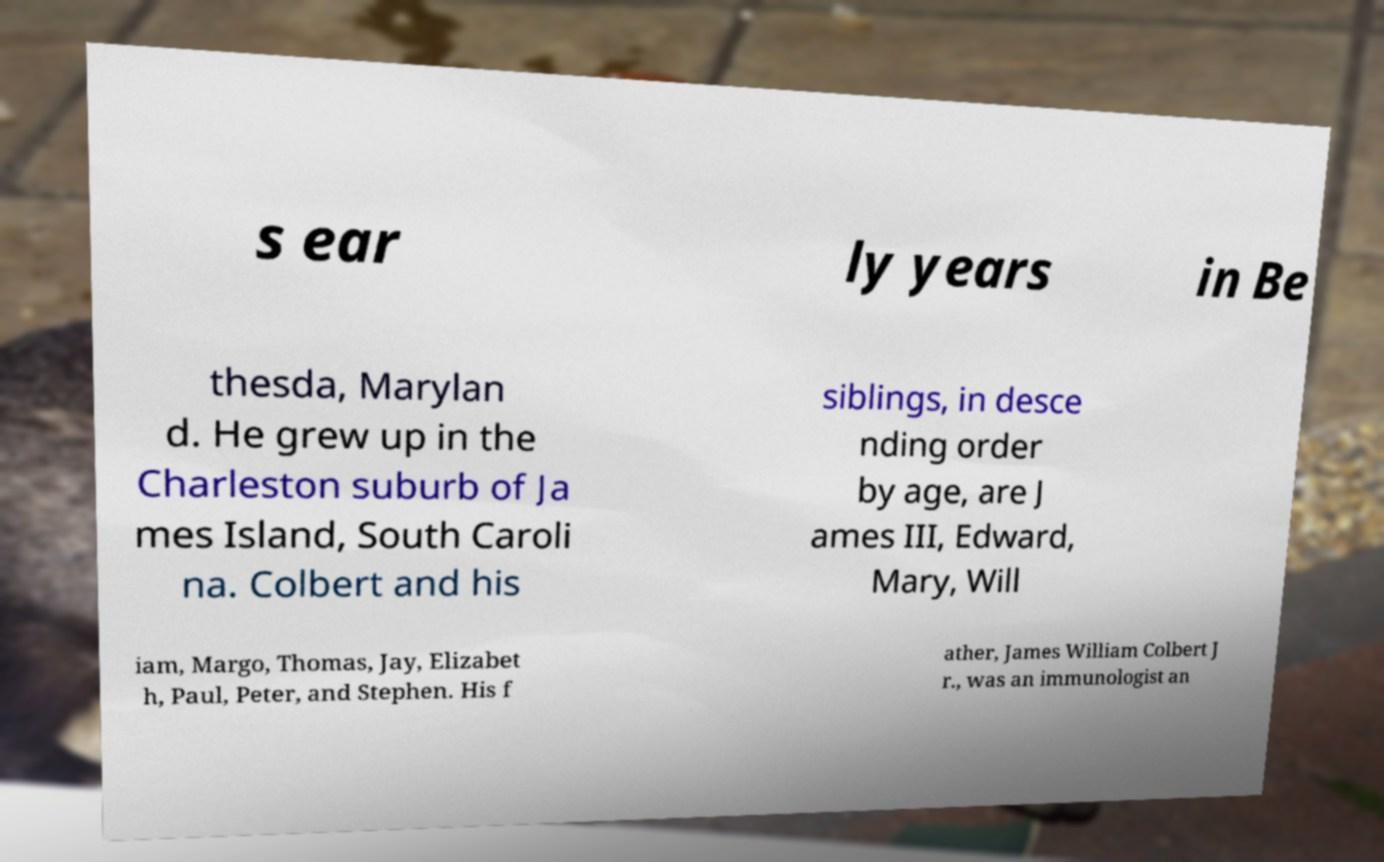Can you read and provide the text displayed in the image?This photo seems to have some interesting text. Can you extract and type it out for me? s ear ly years in Be thesda, Marylan d. He grew up in the Charleston suburb of Ja mes Island, South Caroli na. Colbert and his siblings, in desce nding order by age, are J ames III, Edward, Mary, Will iam, Margo, Thomas, Jay, Elizabet h, Paul, Peter, and Stephen. His f ather, James William Colbert J r., was an immunologist an 